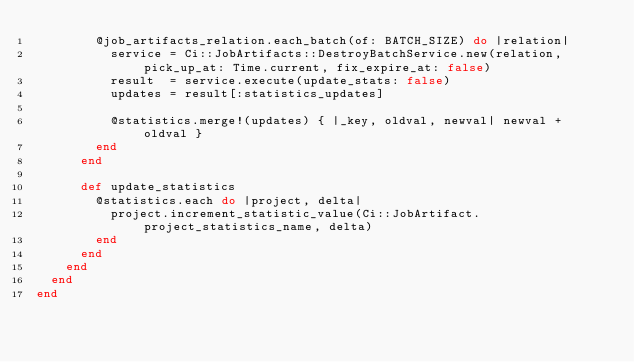<code> <loc_0><loc_0><loc_500><loc_500><_Ruby_>        @job_artifacts_relation.each_batch(of: BATCH_SIZE) do |relation|
          service = Ci::JobArtifacts::DestroyBatchService.new(relation, pick_up_at: Time.current, fix_expire_at: false)
          result  = service.execute(update_stats: false)
          updates = result[:statistics_updates]

          @statistics.merge!(updates) { |_key, oldval, newval| newval + oldval }
        end
      end

      def update_statistics
        @statistics.each do |project, delta|
          project.increment_statistic_value(Ci::JobArtifact.project_statistics_name, delta)
        end
      end
    end
  end
end
</code> 